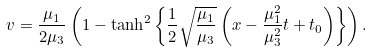<formula> <loc_0><loc_0><loc_500><loc_500>v = \frac { \mu _ { 1 } } { 2 \mu _ { 3 } } \left ( 1 - \tanh ^ { 2 } \left \{ \frac { 1 } { 2 } \sqrt { \frac { \mu _ { 1 } } { \mu _ { 3 } } } \left ( x - \frac { \mu _ { 1 } ^ { 2 } } { \mu _ { 3 } ^ { 2 } } t + t _ { 0 } \right ) \right \} \right ) .</formula> 